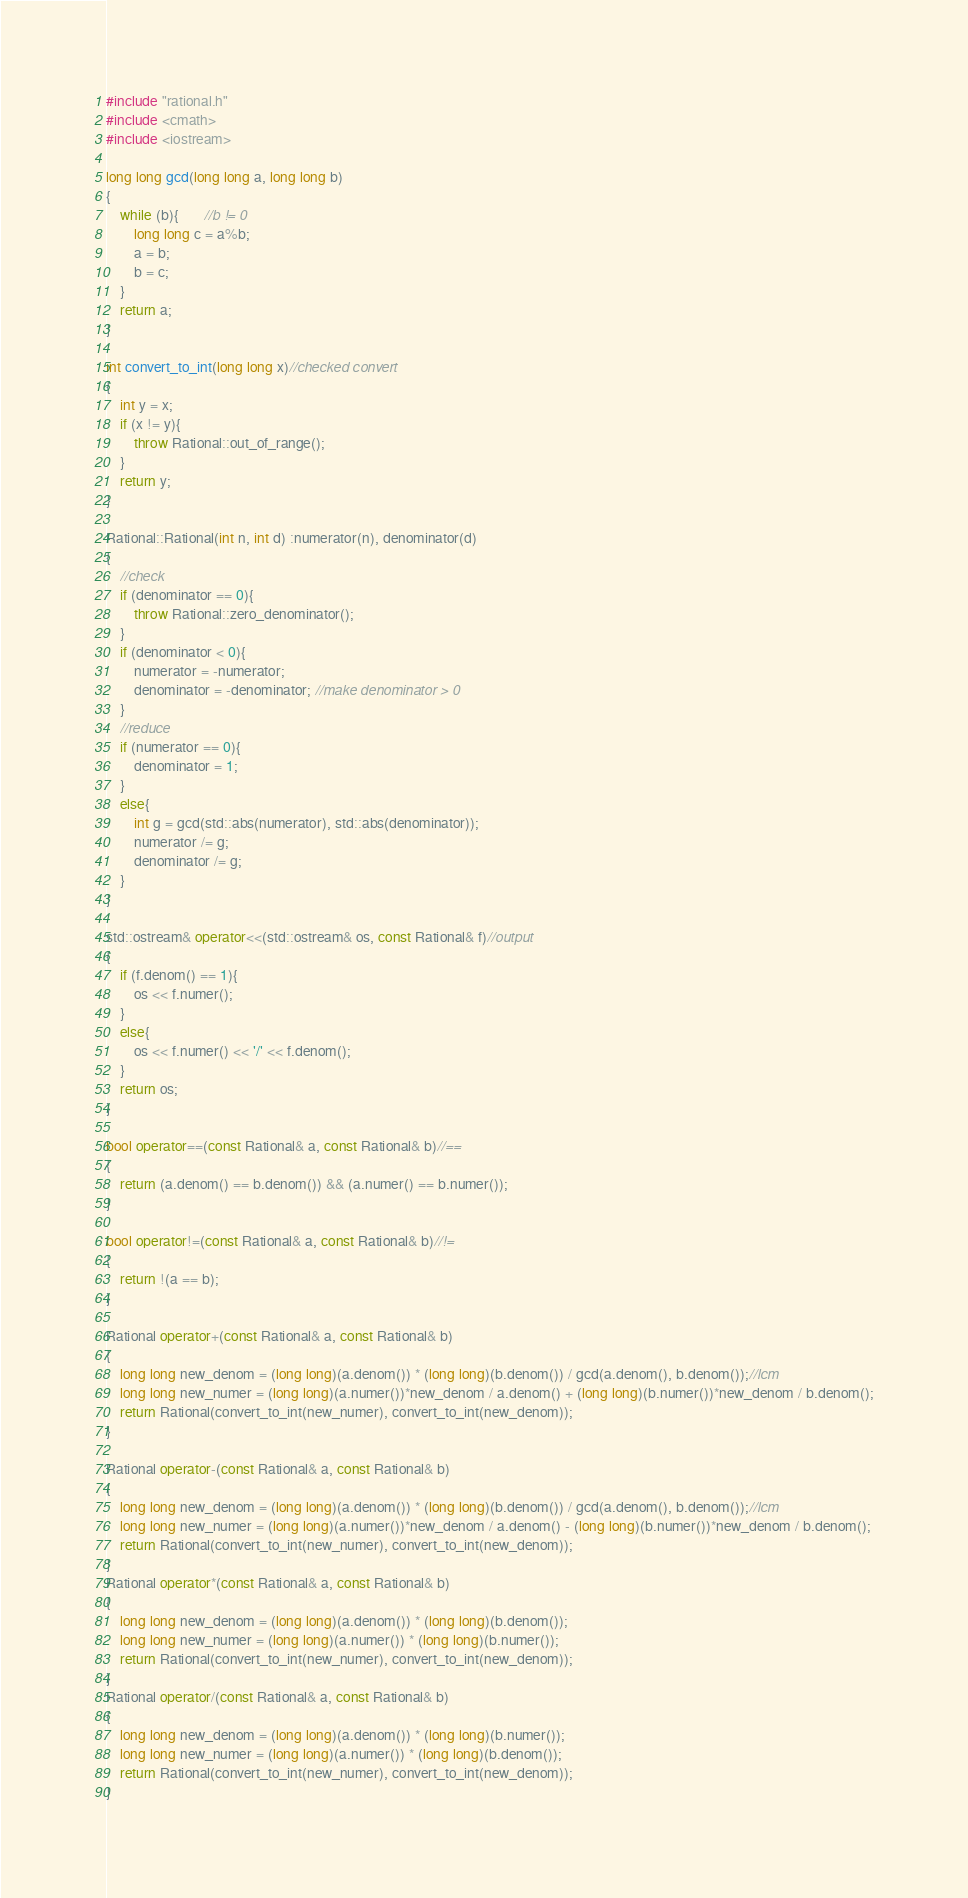Convert code to text. <code><loc_0><loc_0><loc_500><loc_500><_C++_>#include "rational.h"
#include <cmath>
#include <iostream>

long long gcd(long long a, long long b)
{
	while (b){       //b != 0
		long long c = a%b;
		a = b;
		b = c;
	}
	return a;
}

int convert_to_int(long long x)//checked convert
{
	int y = x;
	if (x != y){
		throw Rational::out_of_range();
	}
	return y;
}

Rational::Rational(int n, int d) :numerator(n), denominator(d)
{
	//check
	if (denominator == 0){
		throw Rational::zero_denominator();
	}
	if (denominator < 0){
		numerator = -numerator;
		denominator = -denominator; //make denominator > 0
	}
	//reduce
	if (numerator == 0){
		denominator = 1;
	}
	else{
		int g = gcd(std::abs(numerator), std::abs(denominator));
		numerator /= g;
		denominator /= g;
	}
}

std::ostream& operator<<(std::ostream& os, const Rational& f)//output
{
	if (f.denom() == 1){
		os << f.numer();
	}
	else{
		os << f.numer() << '/' << f.denom();
	}
	return os;
}

bool operator==(const Rational& a, const Rational& b)//==
{
	return (a.denom() == b.denom()) && (a.numer() == b.numer());
}

bool operator!=(const Rational& a, const Rational& b)//!=
{
	return !(a == b);
}

Rational operator+(const Rational& a, const Rational& b)
{
	long long new_denom = (long long)(a.denom()) * (long long)(b.denom()) / gcd(a.denom(), b.denom());//lcm
	long long new_numer = (long long)(a.numer())*new_denom / a.denom() + (long long)(b.numer())*new_denom / b.denom();
	return Rational(convert_to_int(new_numer), convert_to_int(new_denom));
}

Rational operator-(const Rational& a, const Rational& b)
{
	long long new_denom = (long long)(a.denom()) * (long long)(b.denom()) / gcd(a.denom(), b.denom());//lcm
	long long new_numer = (long long)(a.numer())*new_denom / a.denom() - (long long)(b.numer())*new_denom / b.denom();
	return Rational(convert_to_int(new_numer), convert_to_int(new_denom));
}
Rational operator*(const Rational& a, const Rational& b)
{
	long long new_denom = (long long)(a.denom()) * (long long)(b.denom());
	long long new_numer = (long long)(a.numer()) * (long long)(b.numer());
	return Rational(convert_to_int(new_numer), convert_to_int(new_denom));
}
Rational operator/(const Rational& a, const Rational& b)
{
	long long new_denom = (long long)(a.denom()) * (long long)(b.numer());
	long long new_numer = (long long)(a.numer()) * (long long)(b.denom());
	return Rational(convert_to_int(new_numer), convert_to_int(new_denom));
}</code> 